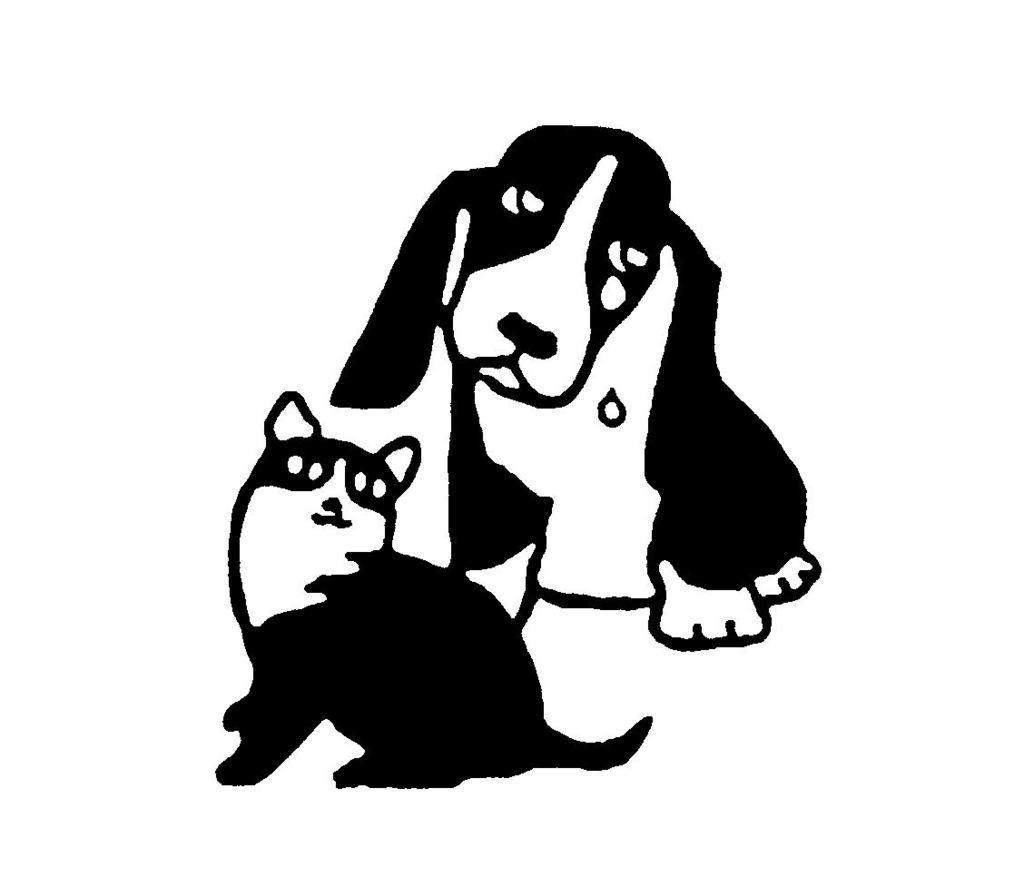In one or two sentences, can you explain what this image depicts? In this image there is a sketch of a dog and a cat. 